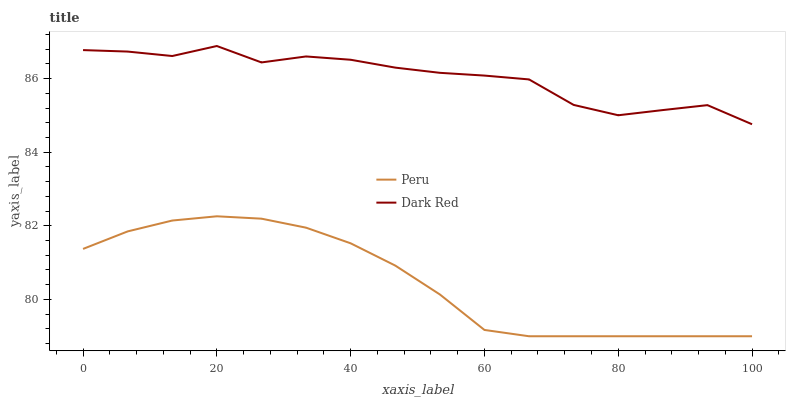Does Peru have the minimum area under the curve?
Answer yes or no. Yes. Does Dark Red have the maximum area under the curve?
Answer yes or no. Yes. Does Peru have the maximum area under the curve?
Answer yes or no. No. Is Peru the smoothest?
Answer yes or no. Yes. Is Dark Red the roughest?
Answer yes or no. Yes. Is Peru the roughest?
Answer yes or no. No. Does Peru have the lowest value?
Answer yes or no. Yes. Does Dark Red have the highest value?
Answer yes or no. Yes. Does Peru have the highest value?
Answer yes or no. No. Is Peru less than Dark Red?
Answer yes or no. Yes. Is Dark Red greater than Peru?
Answer yes or no. Yes. Does Peru intersect Dark Red?
Answer yes or no. No. 